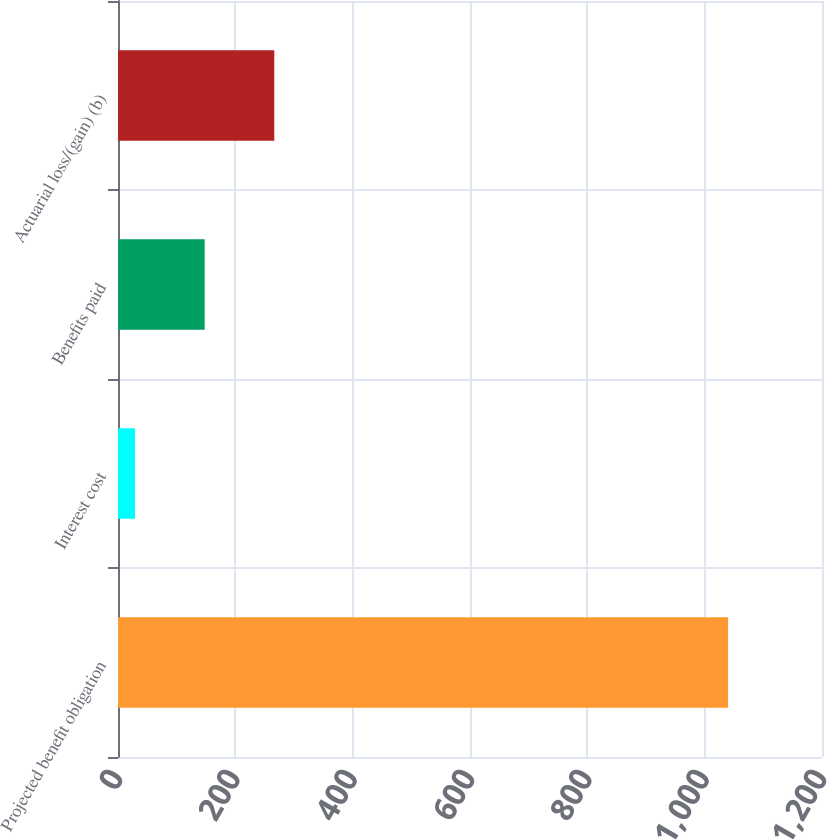<chart> <loc_0><loc_0><loc_500><loc_500><bar_chart><fcel>Projected benefit obligation<fcel>Interest cost<fcel>Benefits paid<fcel>Actuarial loss/(gain) (b)<nl><fcel>1040<fcel>29<fcel>147.7<fcel>266.4<nl></chart> 